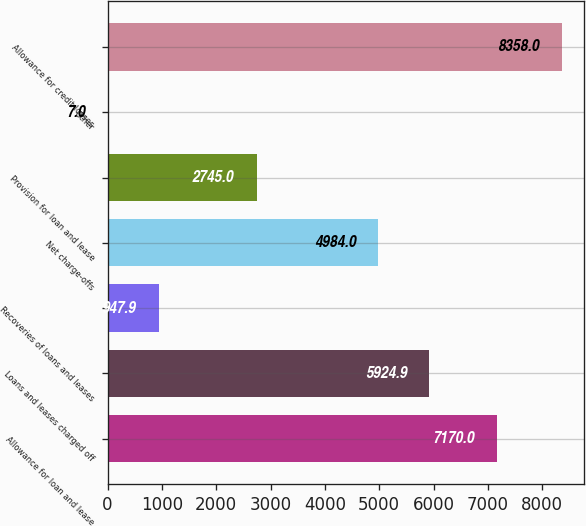Convert chart to OTSL. <chart><loc_0><loc_0><loc_500><loc_500><bar_chart><fcel>Allowance for loan and lease<fcel>Loans and leases charged off<fcel>Recoveries of loans and leases<fcel>Net charge-offs<fcel>Provision for loan and lease<fcel>Other<fcel>Allowance for credit losses<nl><fcel>7170<fcel>5924.9<fcel>947.9<fcel>4984<fcel>2745<fcel>7<fcel>8358<nl></chart> 